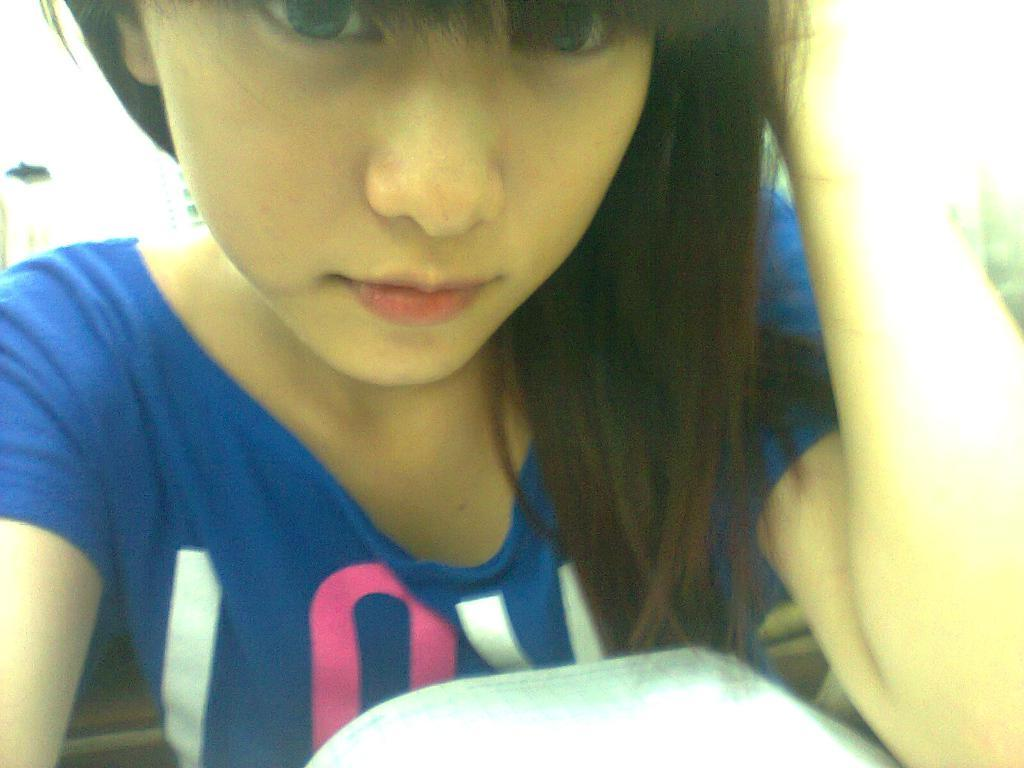What is the woman in the image doing? The woman is sitting in the image. What is the woman wearing in the image? The woman is wearing a blue T-shirt in the image. Can you identify any objects near the woman? There is an object that might be a book in the image. What type of steel is being used to construct the snails in the image? There are no snails or steel present in the image. 